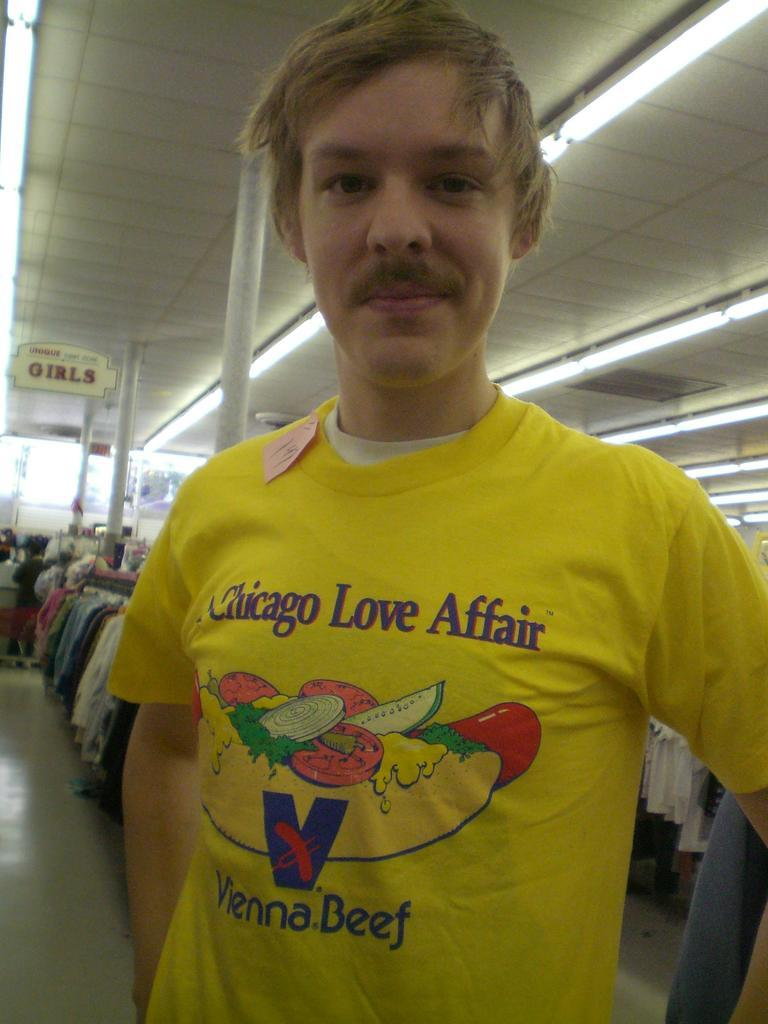What is the main subject of the image? The main subject of the image is a man. What is the man doing in the image? The man is standing in the image. What else can be seen in the image besides the man? There are clothes displayed and pillars in the middle of the image. Reasoning: Let' Let's think step by step in order to produce the conversation. We start by identifying the main subject of the image, which is the man. Then, we describe what the man is doing, which is standing. Next, we mention the other elements in the image, such as the clothes displayed and the pillars. Each question is designed to elicit a specific detail about the image that is known from the provided facts. Absurd Question/Answer: What type of club does the man use to hit the pipe in the image? There is no club or pipe present in the image. What ornament is hanging from the pillars in the image? There is no ornament mentioned in the provided facts, and the image does not show any ornaments hanging from the pillars. 